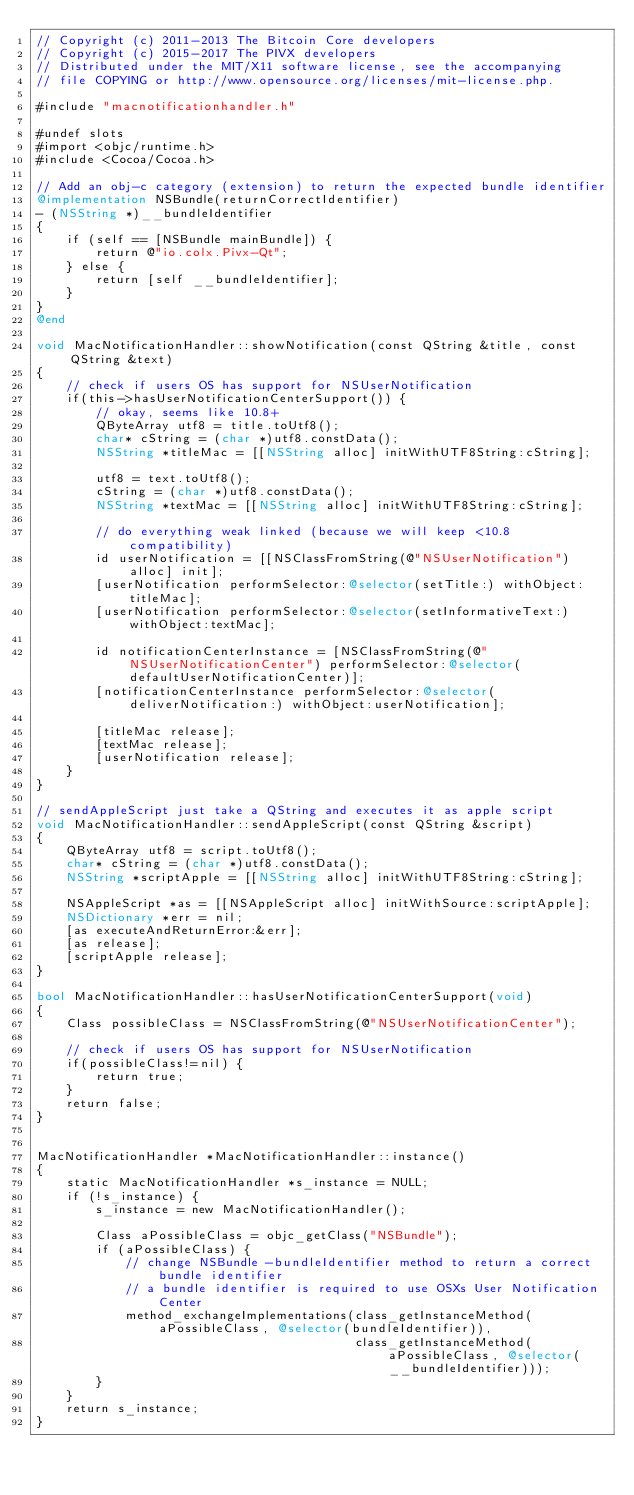Convert code to text. <code><loc_0><loc_0><loc_500><loc_500><_ObjectiveC_>// Copyright (c) 2011-2013 The Bitcoin Core developers
// Copyright (c) 2015-2017 The PIVX developers
// Distributed under the MIT/X11 software license, see the accompanying
// file COPYING or http://www.opensource.org/licenses/mit-license.php.

#include "macnotificationhandler.h"

#undef slots
#import <objc/runtime.h>
#include <Cocoa/Cocoa.h>

// Add an obj-c category (extension) to return the expected bundle identifier
@implementation NSBundle(returnCorrectIdentifier)
- (NSString *)__bundleIdentifier
{
    if (self == [NSBundle mainBundle]) {
        return @"io.colx.Pivx-Qt";
    } else {
        return [self __bundleIdentifier];
    }
}
@end

void MacNotificationHandler::showNotification(const QString &title, const QString &text)
{
    // check if users OS has support for NSUserNotification
    if(this->hasUserNotificationCenterSupport()) {
        // okay, seems like 10.8+
        QByteArray utf8 = title.toUtf8();
        char* cString = (char *)utf8.constData();
        NSString *titleMac = [[NSString alloc] initWithUTF8String:cString];

        utf8 = text.toUtf8();
        cString = (char *)utf8.constData();
        NSString *textMac = [[NSString alloc] initWithUTF8String:cString];

        // do everything weak linked (because we will keep <10.8 compatibility)
        id userNotification = [[NSClassFromString(@"NSUserNotification") alloc] init];
        [userNotification performSelector:@selector(setTitle:) withObject:titleMac];
        [userNotification performSelector:@selector(setInformativeText:) withObject:textMac];

        id notificationCenterInstance = [NSClassFromString(@"NSUserNotificationCenter") performSelector:@selector(defaultUserNotificationCenter)];
        [notificationCenterInstance performSelector:@selector(deliverNotification:) withObject:userNotification];

        [titleMac release];
        [textMac release];
        [userNotification release];
    }
}

// sendAppleScript just take a QString and executes it as apple script
void MacNotificationHandler::sendAppleScript(const QString &script)
{
    QByteArray utf8 = script.toUtf8();
    char* cString = (char *)utf8.constData();
    NSString *scriptApple = [[NSString alloc] initWithUTF8String:cString];

    NSAppleScript *as = [[NSAppleScript alloc] initWithSource:scriptApple];
    NSDictionary *err = nil;
    [as executeAndReturnError:&err];
    [as release];
    [scriptApple release];
}

bool MacNotificationHandler::hasUserNotificationCenterSupport(void)
{
    Class possibleClass = NSClassFromString(@"NSUserNotificationCenter");

    // check if users OS has support for NSUserNotification
    if(possibleClass!=nil) {
        return true;
    }
    return false;
}


MacNotificationHandler *MacNotificationHandler::instance()
{
    static MacNotificationHandler *s_instance = NULL;
    if (!s_instance) {
        s_instance = new MacNotificationHandler();
        
        Class aPossibleClass = objc_getClass("NSBundle");
        if (aPossibleClass) {
            // change NSBundle -bundleIdentifier method to return a correct bundle identifier
            // a bundle identifier is required to use OSXs User Notification Center
            method_exchangeImplementations(class_getInstanceMethod(aPossibleClass, @selector(bundleIdentifier)),
                                           class_getInstanceMethod(aPossibleClass, @selector(__bundleIdentifier)));
        }
    }
    return s_instance;
}
</code> 